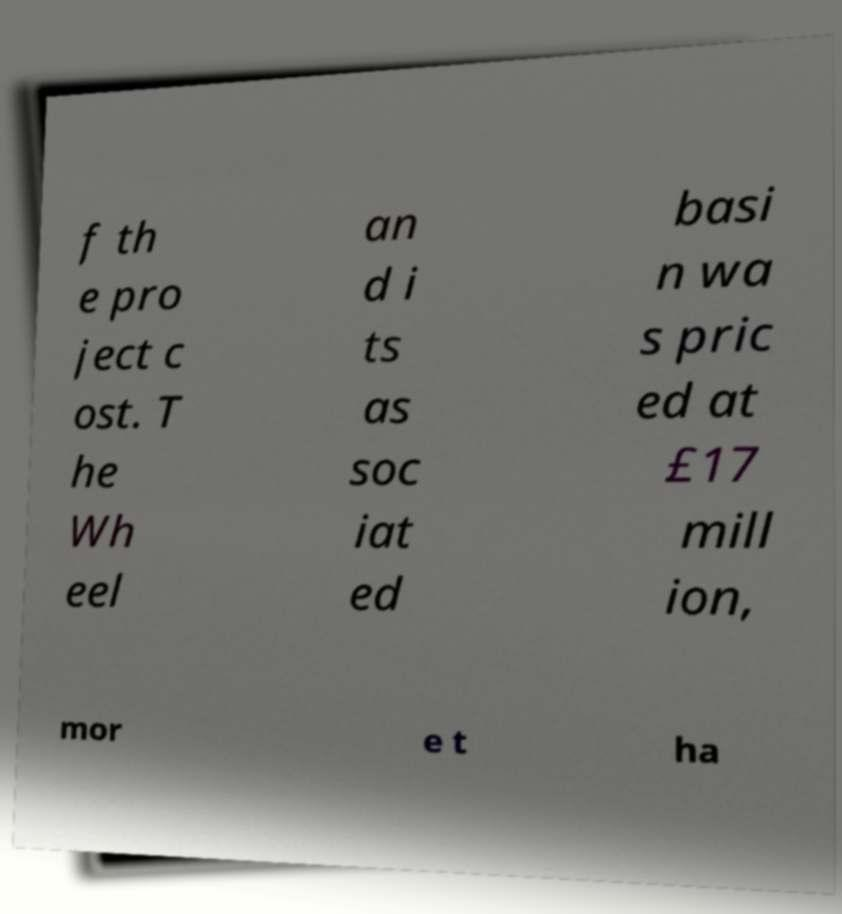For documentation purposes, I need the text within this image transcribed. Could you provide that? f th e pro ject c ost. T he Wh eel an d i ts as soc iat ed basi n wa s pric ed at £17 mill ion, mor e t ha 